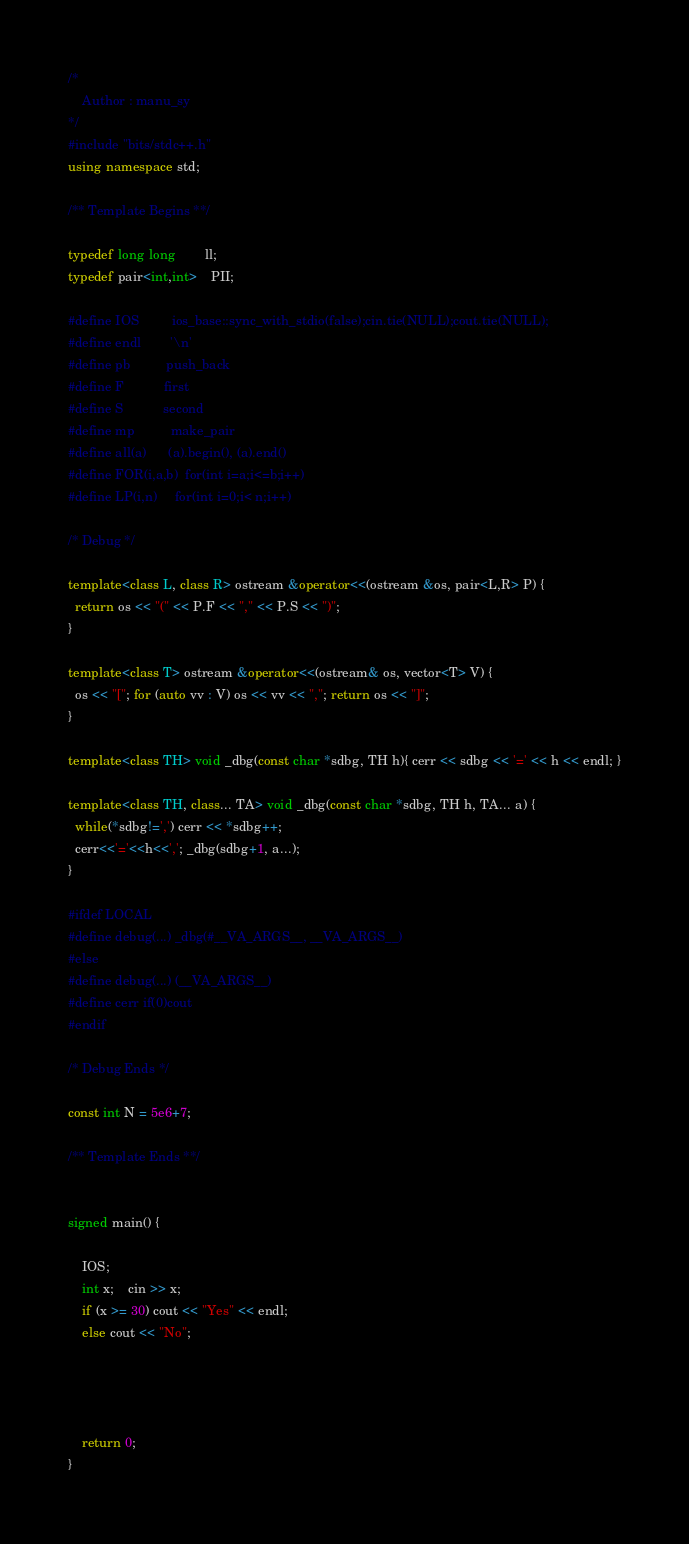<code> <loc_0><loc_0><loc_500><loc_500><_C++_>/*
    Author : manu_sy
*/
#include "bits/stdc++.h"
using namespace std;
 
/** Template Begins **/
 
typedef long long        ll;
typedef pair<int,int>    PII;
 
#define IOS         ios_base::sync_with_stdio(false);cin.tie(NULL);cout.tie(NULL);
#define endl        '\n'
#define pb          push_back
#define F           first
#define S           second
#define mp          make_pair
#define all(a)      (a).begin(), (a).end()
#define FOR(i,a,b)  for(int i=a;i<=b;i++)
#define LP(i,n)     for(int i=0;i< n;i++)
 
/* Debug */
 
template<class L, class R> ostream &operator<<(ostream &os, pair<L,R> P) {
  return os << "(" << P.F << "," << P.S << ")";
} 
 
template<class T> ostream &operator<<(ostream& os, vector<T> V) {
  os << "["; for (auto vv : V) os << vv << ","; return os << "]";
}
 
template<class TH> void _dbg(const char *sdbg, TH h){ cerr << sdbg << '=' << h << endl; }
 
template<class TH, class... TA> void _dbg(const char *sdbg, TH h, TA... a) {
  while(*sdbg!=',') cerr << *sdbg++;
  cerr<<'='<<h<<','; _dbg(sdbg+1, a...);
}
 
#ifdef LOCAL
#define debug(...) _dbg(#__VA_ARGS__, __VA_ARGS__)
#else
#define debug(...) (__VA_ARGS__)
#define cerr if(0)cout
#endif
 
/* Debug Ends */
 
const int N = 5e6+7;
 
/** Template Ends **/

 
signed main() {
 
    IOS;
    int x;	cin >> x;
    if (x >= 30) cout << "Yes" << endl;
    else cout << "No";



 
    return 0;
}





















</code> 